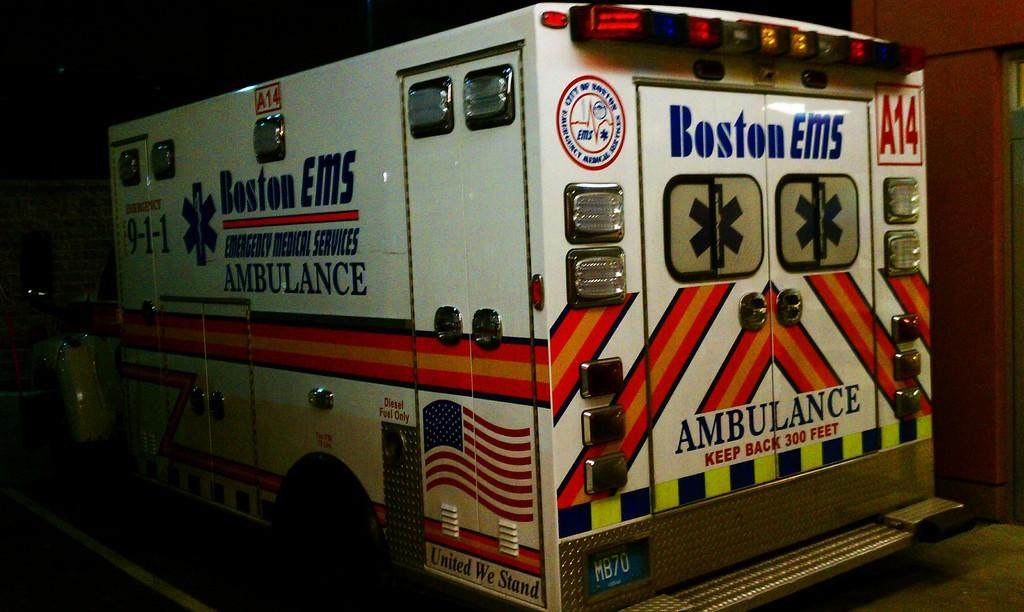What is the main subject in the center of the image? There is a vehicle in the center of the image. What can be seen in the background of the image? There is a wall in the background of the image. How many clocks are hanging on the wall in the image? There are no clocks visible in the image; only a vehicle and a wall are present. What type of ball can be seen bouncing near the vehicle in the image? There is no ball present in the image; only a vehicle and a wall are visible. 